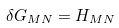Convert formula to latex. <formula><loc_0><loc_0><loc_500><loc_500>\delta G _ { M N } = H _ { M N }</formula> 